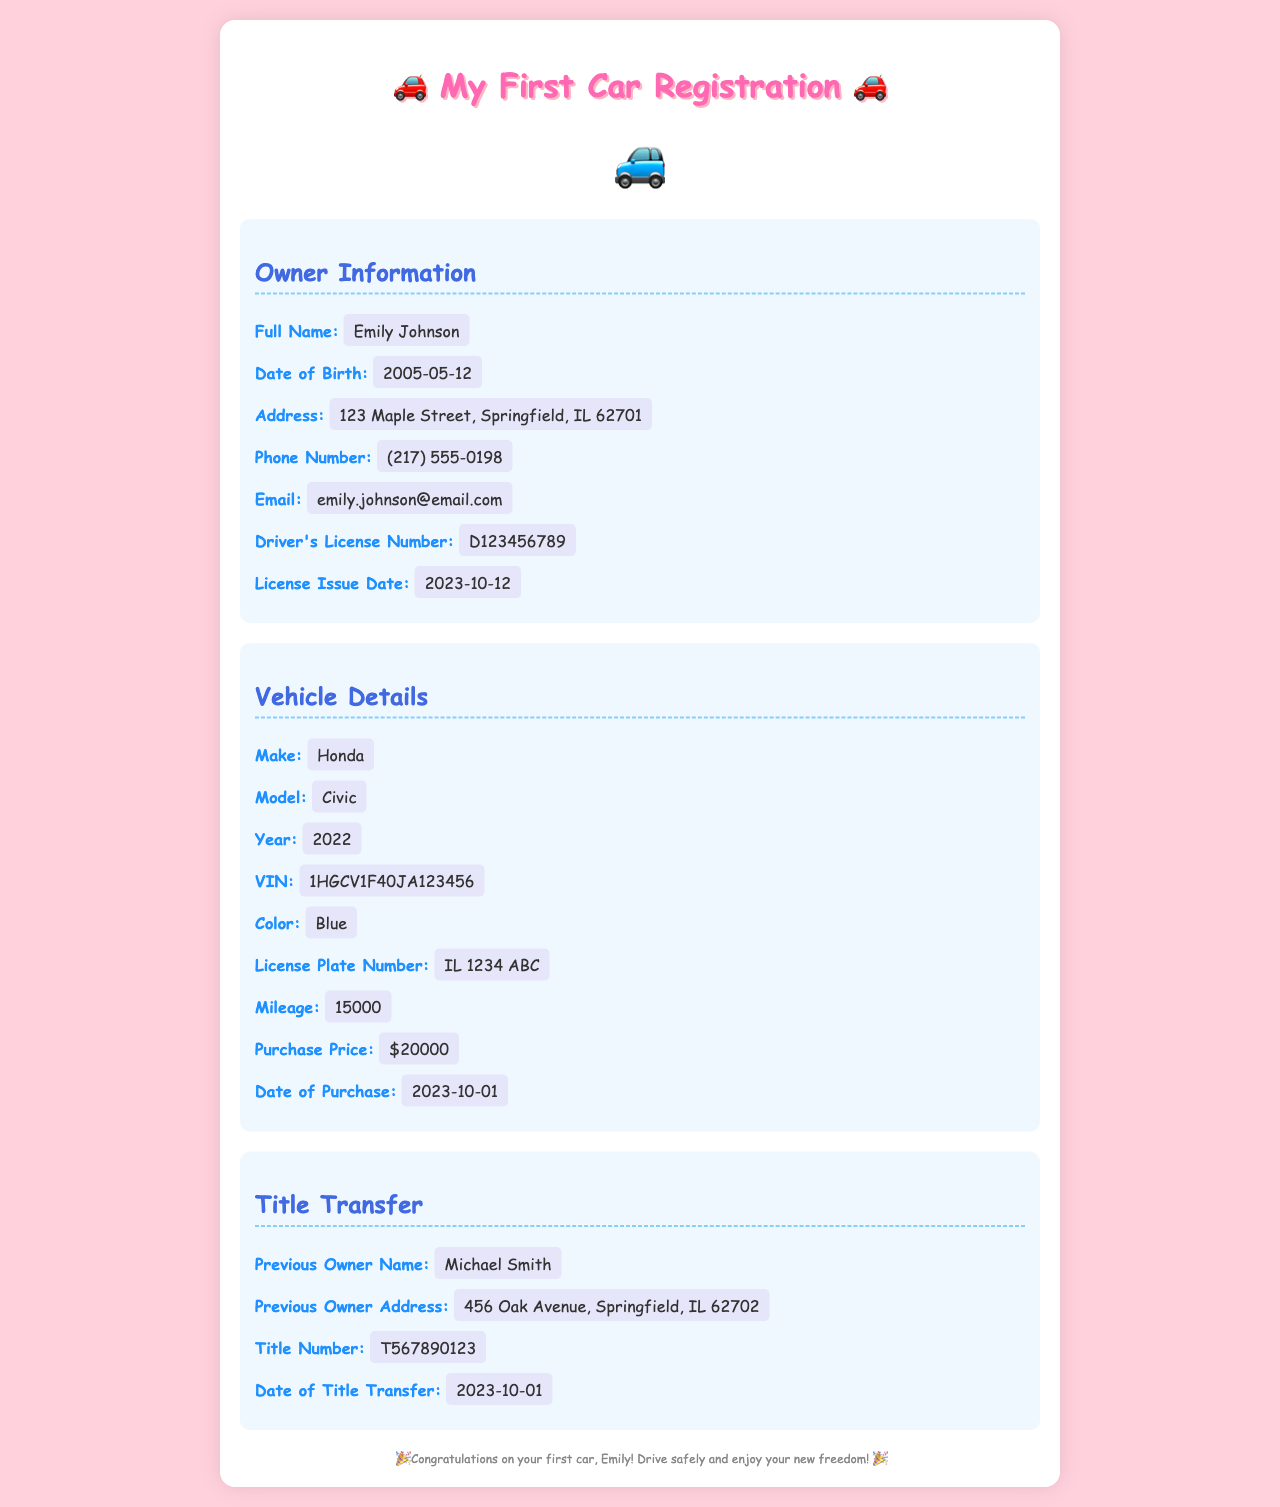What is the full name of the vehicle owner? The owner's full name is displayed under Owner Information.
Answer: Emily Johnson What is the date of birth for the owner? The date of birth is listed in the Owner Information section.
Answer: 2005-05-12 What is the vehicle make? The make of the vehicle can be found in the Vehicle Details section.
Answer: Honda What is the license plate number? The license plate number is provided in the Vehicle Details section.
Answer: IL 1234 ABC Who was the previous owner? The name of the previous owner is found under Title Transfer information.
Answer: Michael Smith How much did the vehicle cost? The purchase price is mentioned in the Vehicle Details section.
Answer: $20000 What is the mileage of the vehicle? The mileage is provided in the Vehicle Details section.
Answer: 15000 What is the title number? The title number is listed under Title Transfer information.
Answer: T567890123 When was the vehicle purchased? The date of purchase is found in the Vehicle Details section.
Answer: 2023-10-01 